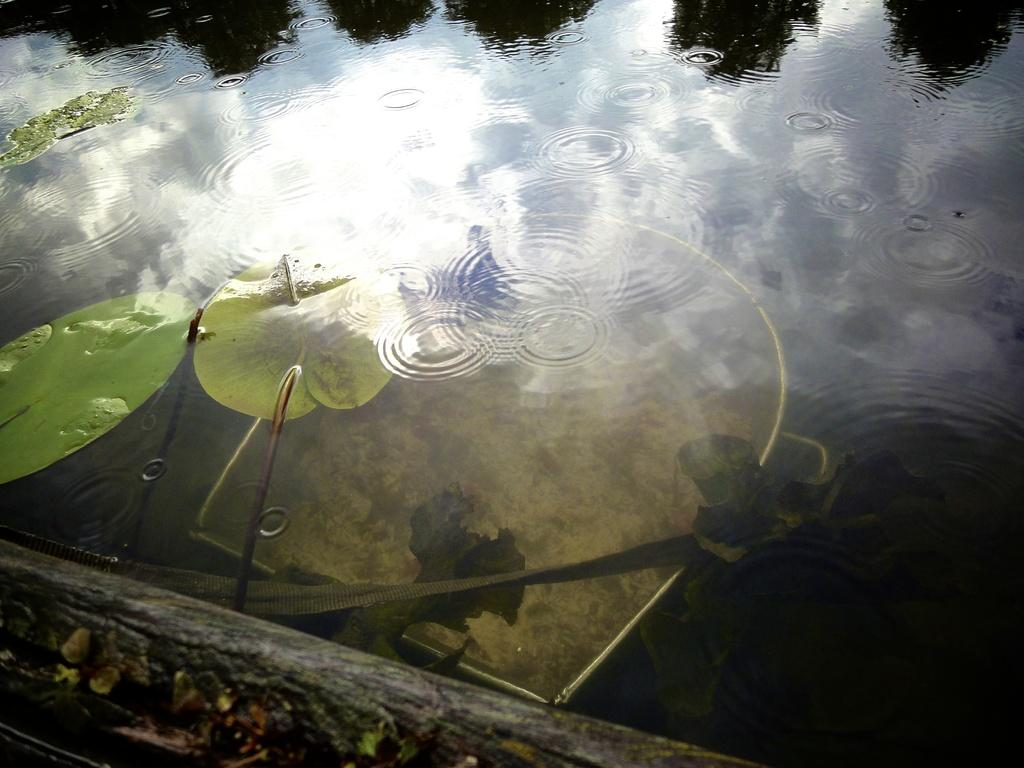What type of vegetation is present in the water in the image? There are lotus leaves in the water. What else can be seen in the water besides the lotus leaves? There is an object in the water. Where is the uncle sitting in the image? There is no uncle present in the image. What type of chin can be seen on the playground equipment in the image? There is no playground equipment or chin present in the image. 